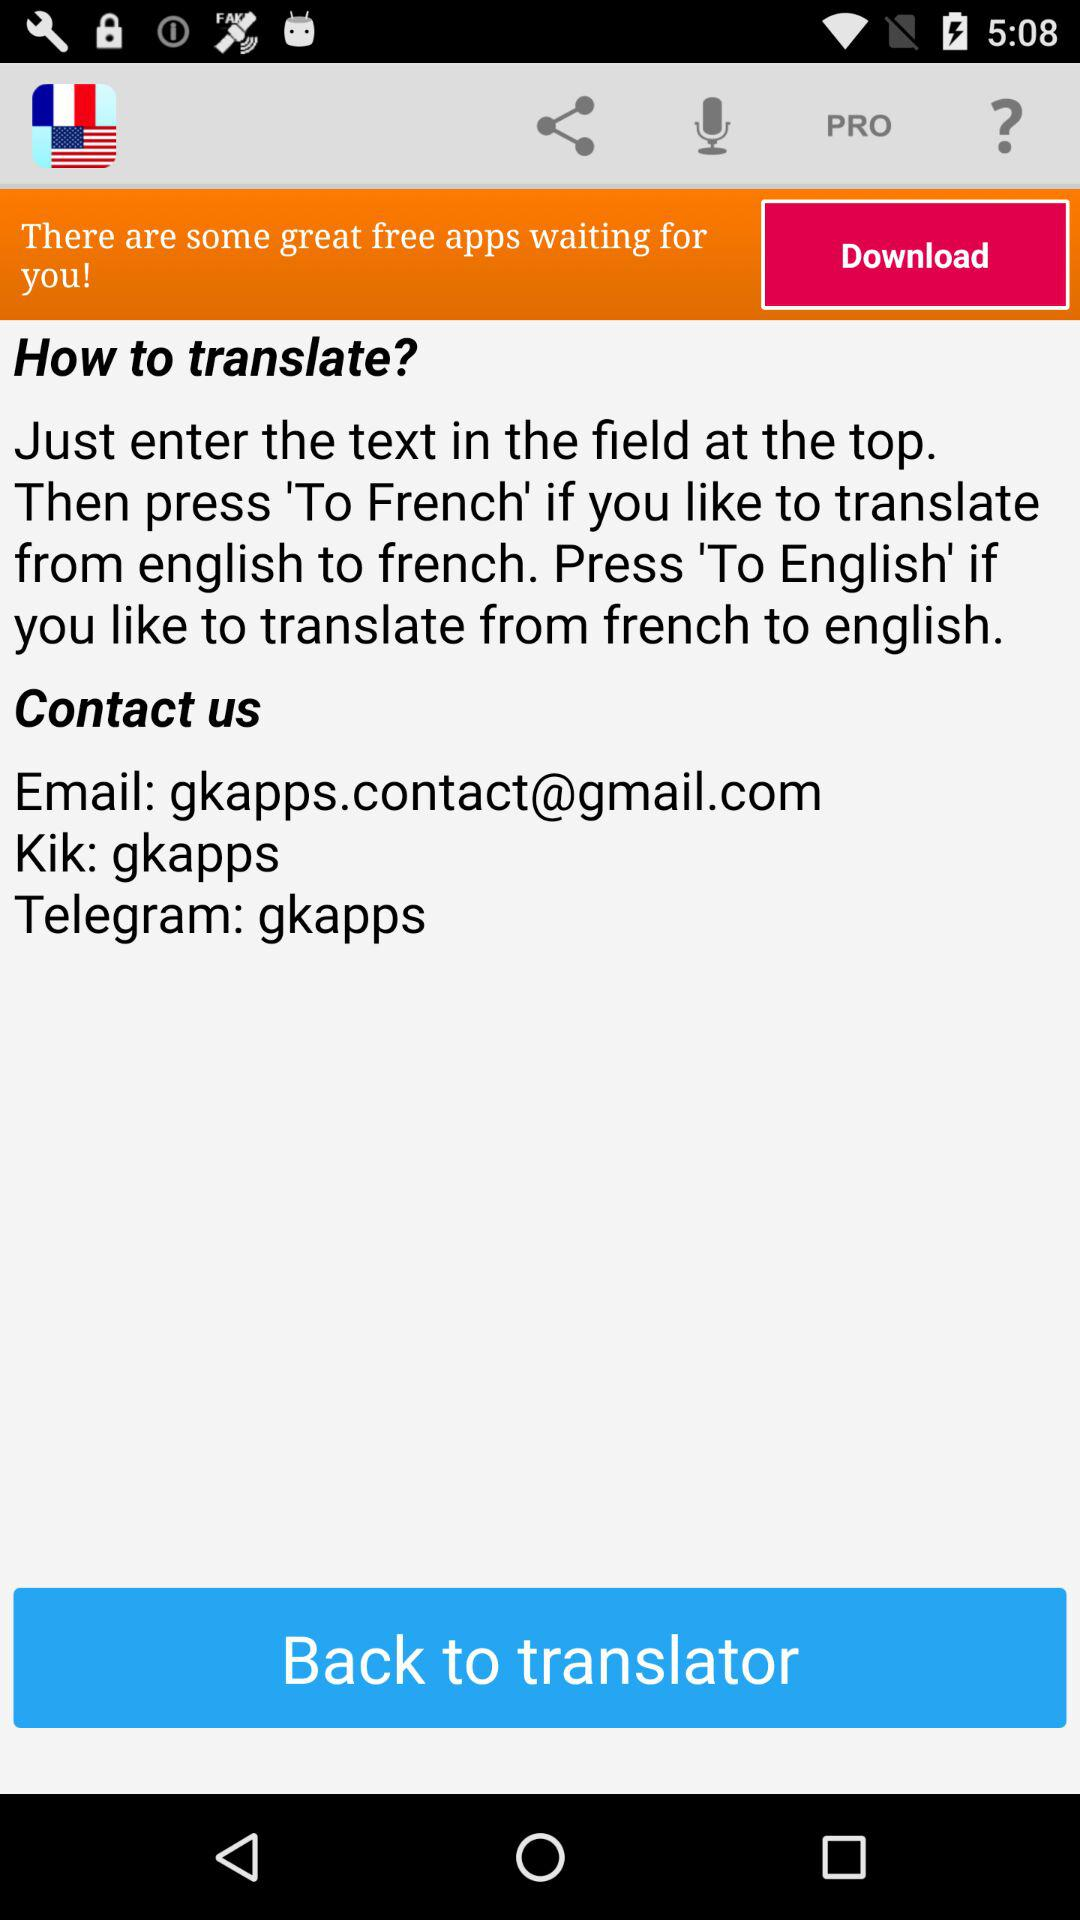What is the email address? The email address is gkapps.contact@gmail.com. 